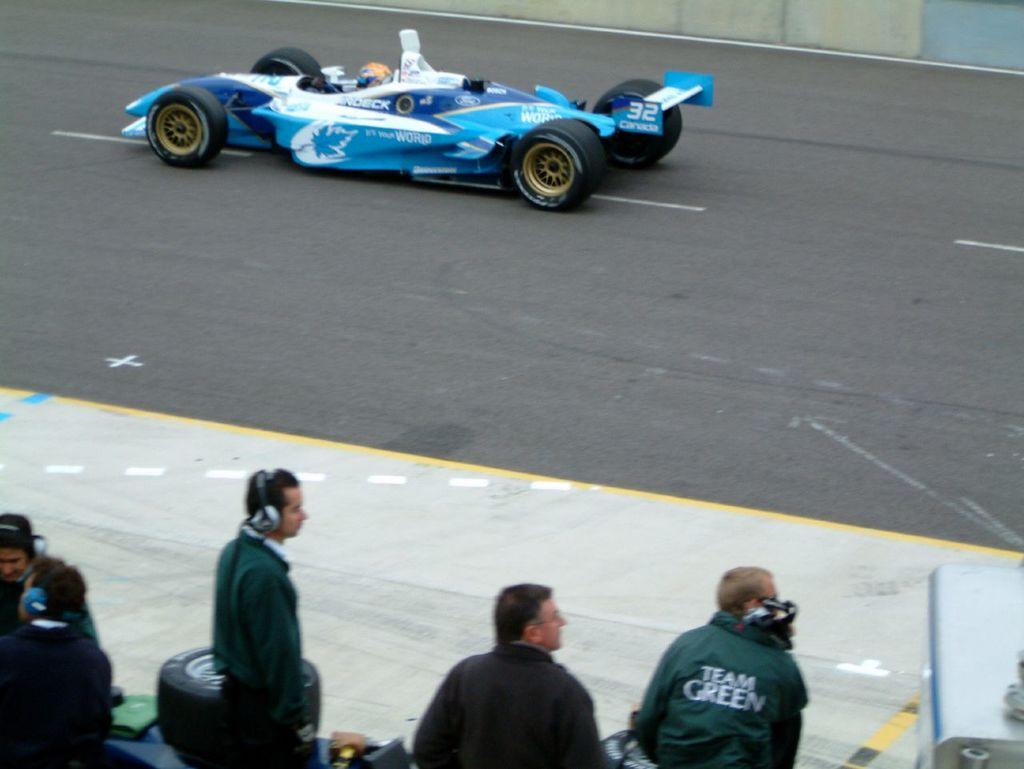What is the main subject of the image? The main subject of the image is a vehicle on the road. Are there any other people or objects in the image besides the vehicle? Yes, there is a group of people standing on the side of the road in the image. What type of collar is being worn by the hospital in the image? There is no hospital present in the image, and therefore no collar can be associated with it. 